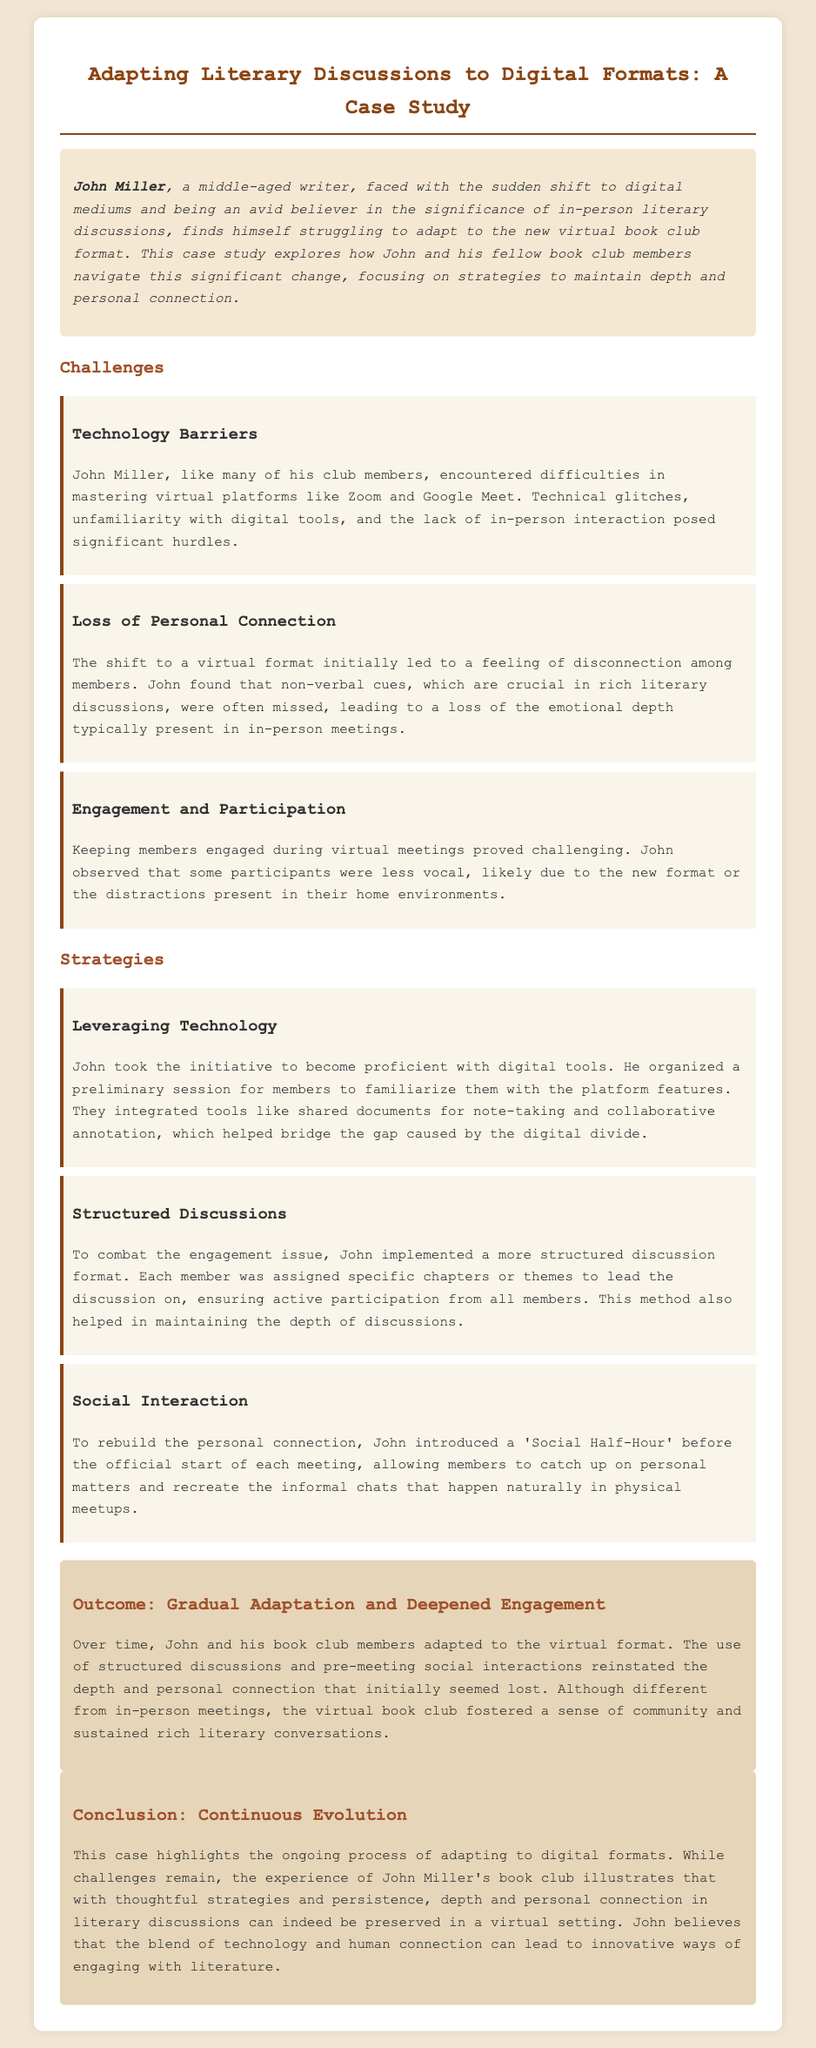What is the name of the writer featured in the case study? The case study centers on a writer named John Miller, who faces challenges in adapting to digital book clubs.
Answer: John Miller What technology was primarily used for virtual meetings? The case study mentions Zoom and Google Meet as the platforms encountered by John and his club members.
Answer: Zoom and Google Meet What was a key challenge related to personal interaction? The case highlighted the loss of non-verbal cues, which are crucial for emotional depth in discussions.
Answer: Loss of non-verbal cues What strategy did John implement to encourage participation? John assigned specific chapters or themes to each member, enhancing engagement through structured discussions.
Answer: Structured discussions What initiative did John introduce to rebuild personal connection? John initiated a 'Social Half-Hour' before meetings to foster informal chats among members.
Answer: Social Half-Hour What was the primary outcome of the adaptation to virtual formats? The gradual adaptation and deepened engagement among the book club members were a key outcome of their transition.
Answer: Gradual adaptation and deepened engagement How did John help members with technology barriers? He organized a preliminary session to familiarize them with the digital platform features.
Answer: Preliminary session What conclusion does John draw about digital literary discussions? John believes that technology combined with human connection can lead to innovative literature engagement methods.
Answer: Innovative ways of engaging with literature 